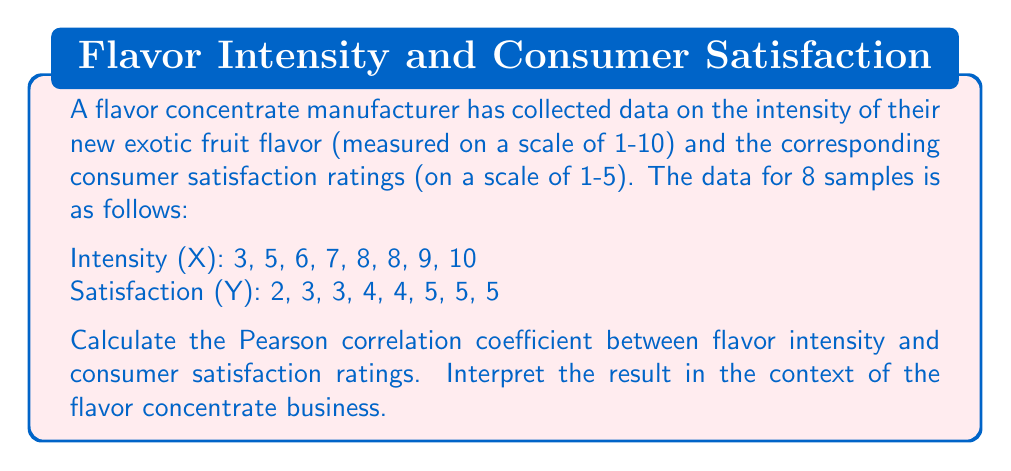Solve this math problem. To calculate the Pearson correlation coefficient, we'll use the formula:

$$ r = \frac{\sum_{i=1}^{n} (x_i - \bar{x})(y_i - \bar{y})}{\sqrt{\sum_{i=1}^{n} (x_i - \bar{x})^2 \sum_{i=1}^{n} (y_i - \bar{y})^2}} $$

Where $x_i$ and $y_i$ are the individual values, and $\bar{x}$ and $\bar{y}$ are the means of X and Y respectively.

Step 1: Calculate the means
$\bar{x} = \frac{3 + 5 + 6 + 7 + 8 + 8 + 9 + 10}{8} = 7$
$\bar{y} = \frac{2 + 3 + 3 + 4 + 4 + 5 + 5 + 5}{8} = 3.875$

Step 2: Calculate $(x_i - \bar{x})$, $(y_i - \bar{y})$, $(x_i - \bar{x})^2$, $(y_i - \bar{y})^2$, and $(x_i - \bar{x})(y_i - \bar{y})$ for each pair

Step 3: Sum up the calculated values
$\sum (x_i - \bar{x})(y_i - \bar{y}) = 20.875$
$\sum (x_i - \bar{x})^2 = 50$
$\sum (y_i - \bar{y})^2 = 8.875$

Step 4: Apply the formula
$$ r = \frac{20.875}{\sqrt{50 \times 8.875}} = \frac{20.875}{21.08} = 0.990 $$

The Pearson correlation coefficient is approximately 0.990.
Answer: The Pearson correlation coefficient is 0.990, indicating a very strong positive correlation between flavor intensity and consumer satisfaction ratings. This suggests that as the intensity of the exotic fruit flavor increases, consumer satisfaction tends to increase as well. For the flavor concentrate manufacturer, this implies that developing more intense flavors could lead to higher consumer satisfaction, potentially driving sales and market success for their new and exotic flavor concentrates. 